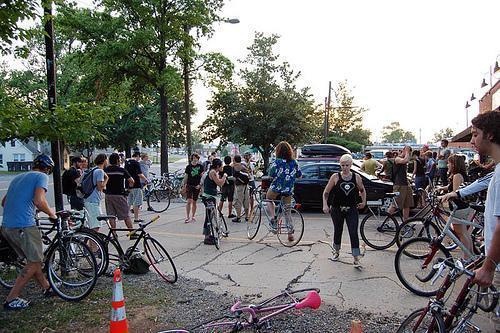How many bicycles are there?
Give a very brief answer. 4. How many people are there?
Give a very brief answer. 4. 